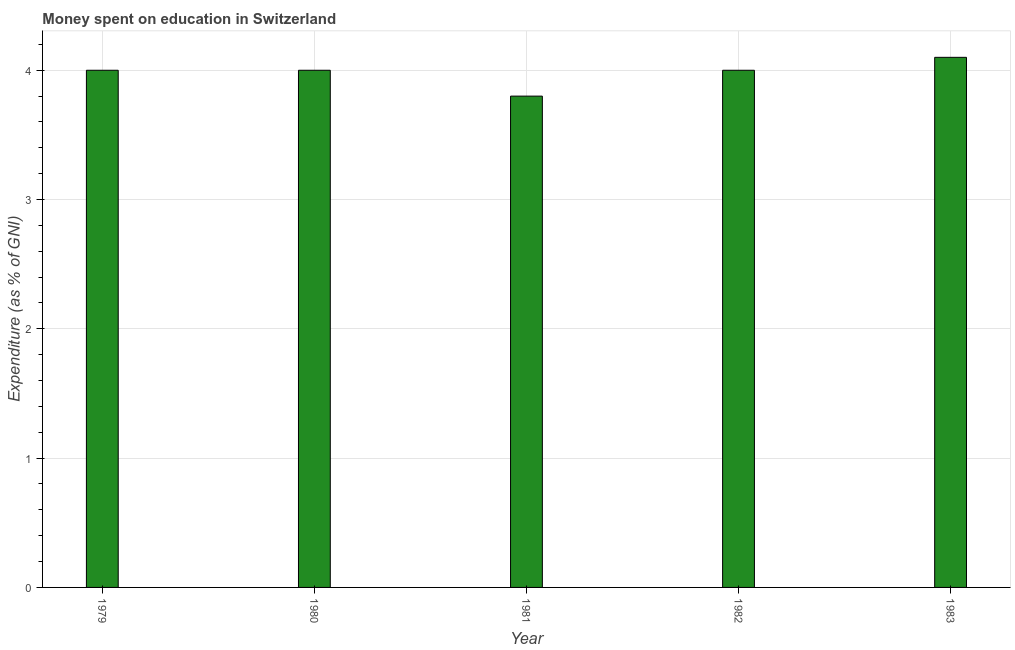Does the graph contain grids?
Offer a very short reply. Yes. What is the title of the graph?
Provide a short and direct response. Money spent on education in Switzerland. What is the label or title of the X-axis?
Provide a succinct answer. Year. What is the label or title of the Y-axis?
Give a very brief answer. Expenditure (as % of GNI). What is the expenditure on education in 1979?
Keep it short and to the point. 4. In which year was the expenditure on education maximum?
Offer a terse response. 1983. What is the sum of the expenditure on education?
Your answer should be very brief. 19.9. What is the average expenditure on education per year?
Your answer should be very brief. 3.98. In how many years, is the expenditure on education greater than 2.8 %?
Keep it short and to the point. 5. What is the ratio of the expenditure on education in 1981 to that in 1983?
Make the answer very short. 0.93. Is the expenditure on education in 1979 less than that in 1981?
Ensure brevity in your answer.  No. Is the sum of the expenditure on education in 1980 and 1983 greater than the maximum expenditure on education across all years?
Offer a terse response. Yes. What is the difference between the highest and the lowest expenditure on education?
Make the answer very short. 0.3. In how many years, is the expenditure on education greater than the average expenditure on education taken over all years?
Make the answer very short. 4. How many bars are there?
Your answer should be very brief. 5. Are all the bars in the graph horizontal?
Keep it short and to the point. No. What is the difference between two consecutive major ticks on the Y-axis?
Your response must be concise. 1. What is the Expenditure (as % of GNI) in 1979?
Your response must be concise. 4. What is the Expenditure (as % of GNI) of 1980?
Offer a terse response. 4. What is the Expenditure (as % of GNI) of 1981?
Ensure brevity in your answer.  3.8. What is the Expenditure (as % of GNI) of 1983?
Offer a terse response. 4.1. What is the difference between the Expenditure (as % of GNI) in 1979 and 1981?
Your answer should be compact. 0.2. What is the difference between the Expenditure (as % of GNI) in 1979 and 1982?
Your response must be concise. 0. What is the difference between the Expenditure (as % of GNI) in 1980 and 1981?
Make the answer very short. 0.2. What is the difference between the Expenditure (as % of GNI) in 1980 and 1982?
Keep it short and to the point. 0. What is the difference between the Expenditure (as % of GNI) in 1980 and 1983?
Provide a short and direct response. -0.1. What is the difference between the Expenditure (as % of GNI) in 1981 and 1982?
Offer a terse response. -0.2. What is the ratio of the Expenditure (as % of GNI) in 1979 to that in 1981?
Your answer should be very brief. 1.05. What is the ratio of the Expenditure (as % of GNI) in 1979 to that in 1982?
Your answer should be very brief. 1. What is the ratio of the Expenditure (as % of GNI) in 1980 to that in 1981?
Your response must be concise. 1.05. What is the ratio of the Expenditure (as % of GNI) in 1980 to that in 1982?
Your answer should be very brief. 1. What is the ratio of the Expenditure (as % of GNI) in 1980 to that in 1983?
Offer a very short reply. 0.98. What is the ratio of the Expenditure (as % of GNI) in 1981 to that in 1983?
Your response must be concise. 0.93. 